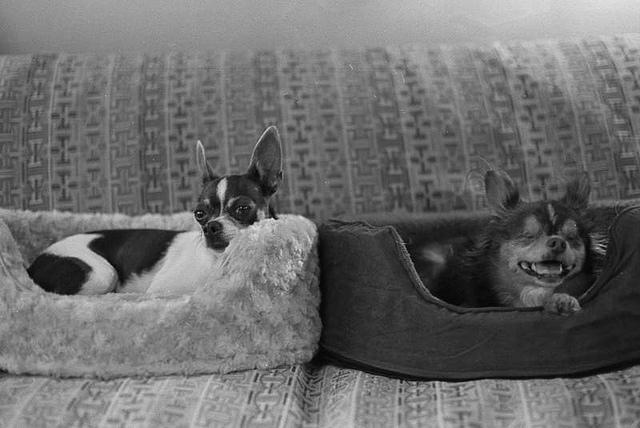How many dogs are in their beds?
Short answer required. 2. Are the dogs sleeping in different beds?
Answer briefly. Yes. Is the dog on the right happy or sad?
Write a very short answer. Happy. 